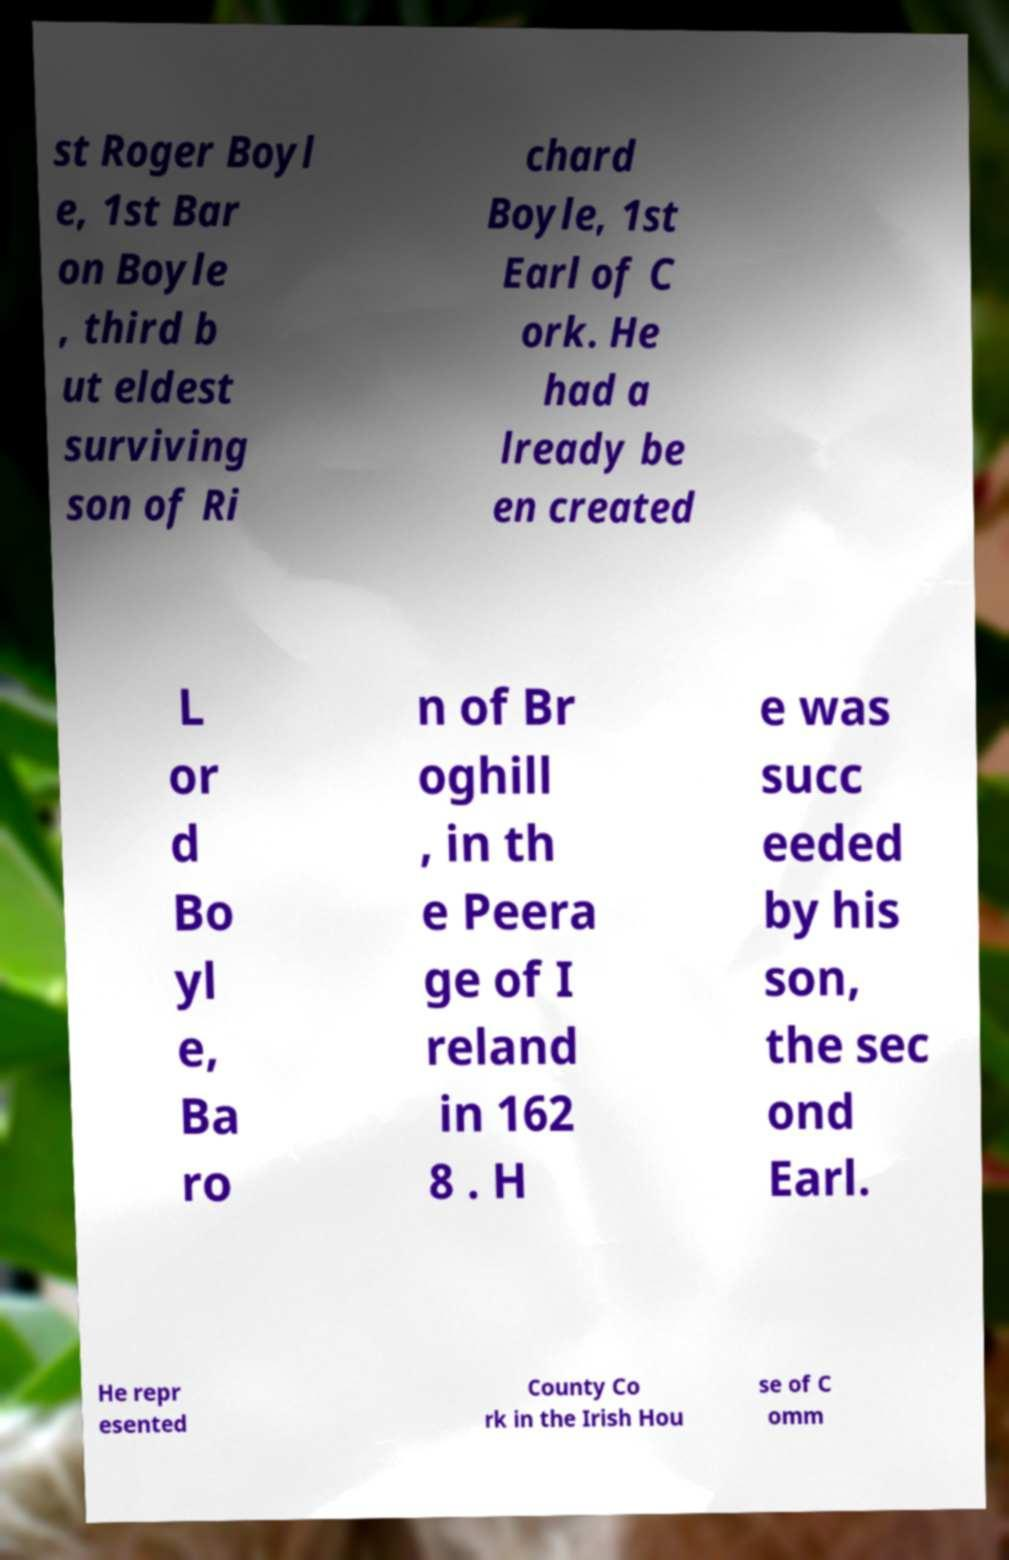What messages or text are displayed in this image? I need them in a readable, typed format. st Roger Boyl e, 1st Bar on Boyle , third b ut eldest surviving son of Ri chard Boyle, 1st Earl of C ork. He had a lready be en created L or d Bo yl e, Ba ro n of Br oghill , in th e Peera ge of I reland in 162 8 . H e was succ eeded by his son, the sec ond Earl. He repr esented County Co rk in the Irish Hou se of C omm 